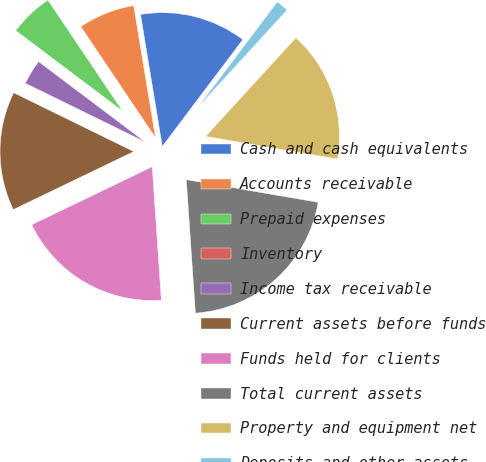Convert chart to OTSL. <chart><loc_0><loc_0><loc_500><loc_500><pie_chart><fcel>Cash and cash equivalents<fcel>Accounts receivable<fcel>Prepaid expenses<fcel>Inventory<fcel>Income tax receivable<fcel>Current assets before funds<fcel>Funds held for clients<fcel>Total current assets<fcel>Property and equipment net<fcel>Deposits and other assets<nl><fcel>12.88%<fcel>6.82%<fcel>5.3%<fcel>0.0%<fcel>3.03%<fcel>14.39%<fcel>18.94%<fcel>21.21%<fcel>15.91%<fcel>1.52%<nl></chart> 